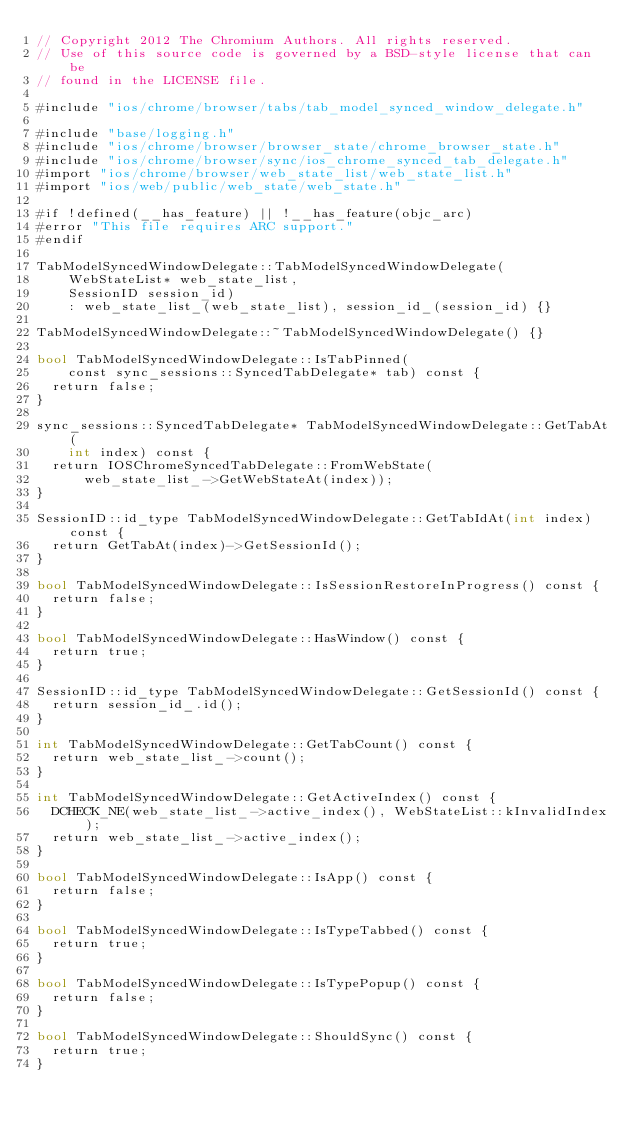<code> <loc_0><loc_0><loc_500><loc_500><_ObjectiveC_>// Copyright 2012 The Chromium Authors. All rights reserved.
// Use of this source code is governed by a BSD-style license that can be
// found in the LICENSE file.

#include "ios/chrome/browser/tabs/tab_model_synced_window_delegate.h"

#include "base/logging.h"
#include "ios/chrome/browser/browser_state/chrome_browser_state.h"
#include "ios/chrome/browser/sync/ios_chrome_synced_tab_delegate.h"
#import "ios/chrome/browser/web_state_list/web_state_list.h"
#import "ios/web/public/web_state/web_state.h"

#if !defined(__has_feature) || !__has_feature(objc_arc)
#error "This file requires ARC support."
#endif

TabModelSyncedWindowDelegate::TabModelSyncedWindowDelegate(
    WebStateList* web_state_list,
    SessionID session_id)
    : web_state_list_(web_state_list), session_id_(session_id) {}

TabModelSyncedWindowDelegate::~TabModelSyncedWindowDelegate() {}

bool TabModelSyncedWindowDelegate::IsTabPinned(
    const sync_sessions::SyncedTabDelegate* tab) const {
  return false;
}

sync_sessions::SyncedTabDelegate* TabModelSyncedWindowDelegate::GetTabAt(
    int index) const {
  return IOSChromeSyncedTabDelegate::FromWebState(
      web_state_list_->GetWebStateAt(index));
}

SessionID::id_type TabModelSyncedWindowDelegate::GetTabIdAt(int index) const {
  return GetTabAt(index)->GetSessionId();
}

bool TabModelSyncedWindowDelegate::IsSessionRestoreInProgress() const {
  return false;
}

bool TabModelSyncedWindowDelegate::HasWindow() const {
  return true;
}

SessionID::id_type TabModelSyncedWindowDelegate::GetSessionId() const {
  return session_id_.id();
}

int TabModelSyncedWindowDelegate::GetTabCount() const {
  return web_state_list_->count();
}

int TabModelSyncedWindowDelegate::GetActiveIndex() const {
  DCHECK_NE(web_state_list_->active_index(), WebStateList::kInvalidIndex);
  return web_state_list_->active_index();
}

bool TabModelSyncedWindowDelegate::IsApp() const {
  return false;
}

bool TabModelSyncedWindowDelegate::IsTypeTabbed() const {
  return true;
}

bool TabModelSyncedWindowDelegate::IsTypePopup() const {
  return false;
}

bool TabModelSyncedWindowDelegate::ShouldSync() const {
  return true;
}
</code> 